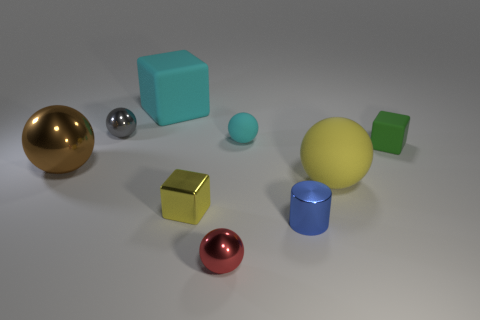There is a sphere that is the same color as the small metallic cube; what is its size?
Your answer should be very brief. Large. Are there any small cyan objects that have the same material as the big cyan cube?
Offer a terse response. Yes. How many objects are either tiny metallic balls left of the tiny yellow object or balls behind the yellow matte ball?
Ensure brevity in your answer.  3. There is a red object; is it the same shape as the object that is left of the small gray metallic ball?
Keep it short and to the point. Yes. What number of other objects are the same shape as the large yellow thing?
Offer a terse response. 4. What number of things are either large purple metallic cylinders or cyan objects?
Give a very brief answer. 2. Is the big block the same color as the tiny rubber ball?
Provide a succinct answer. Yes. There is a big rubber object behind the tiny metallic sphere behind the large brown object; what is its shape?
Provide a succinct answer. Cube. Is the number of brown metallic balls less than the number of metallic balls?
Offer a terse response. Yes. What is the size of the cube that is on the left side of the metal cylinder and behind the large yellow sphere?
Give a very brief answer. Large. 